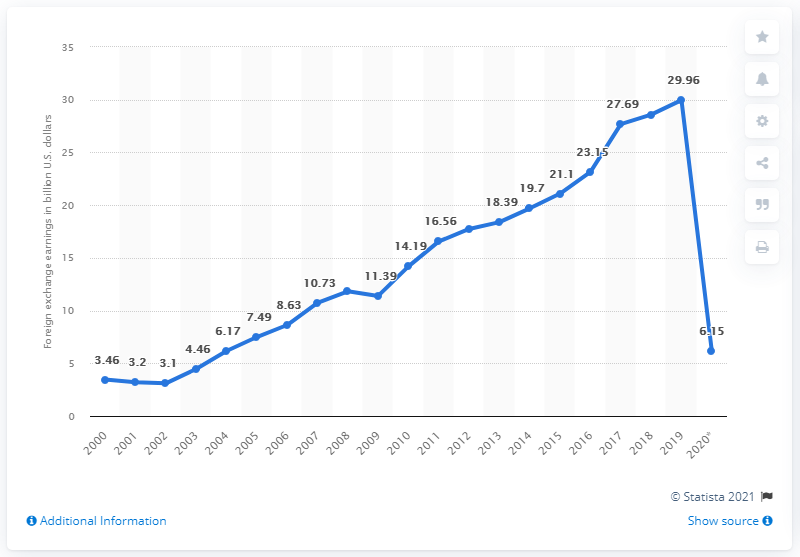List a handful of essential elements in this visual. In 2019, India's tourism exchange earnings reached a total of 29.96 billion US dollars. In 2020, the total foreign exchange earnings from tourism in India were estimated to be approximately 36.11 billion U.S. dollars. In 2020, the foreign exchange earnings from tourism in India were approximately 6.15 billion U.S. dollars. 